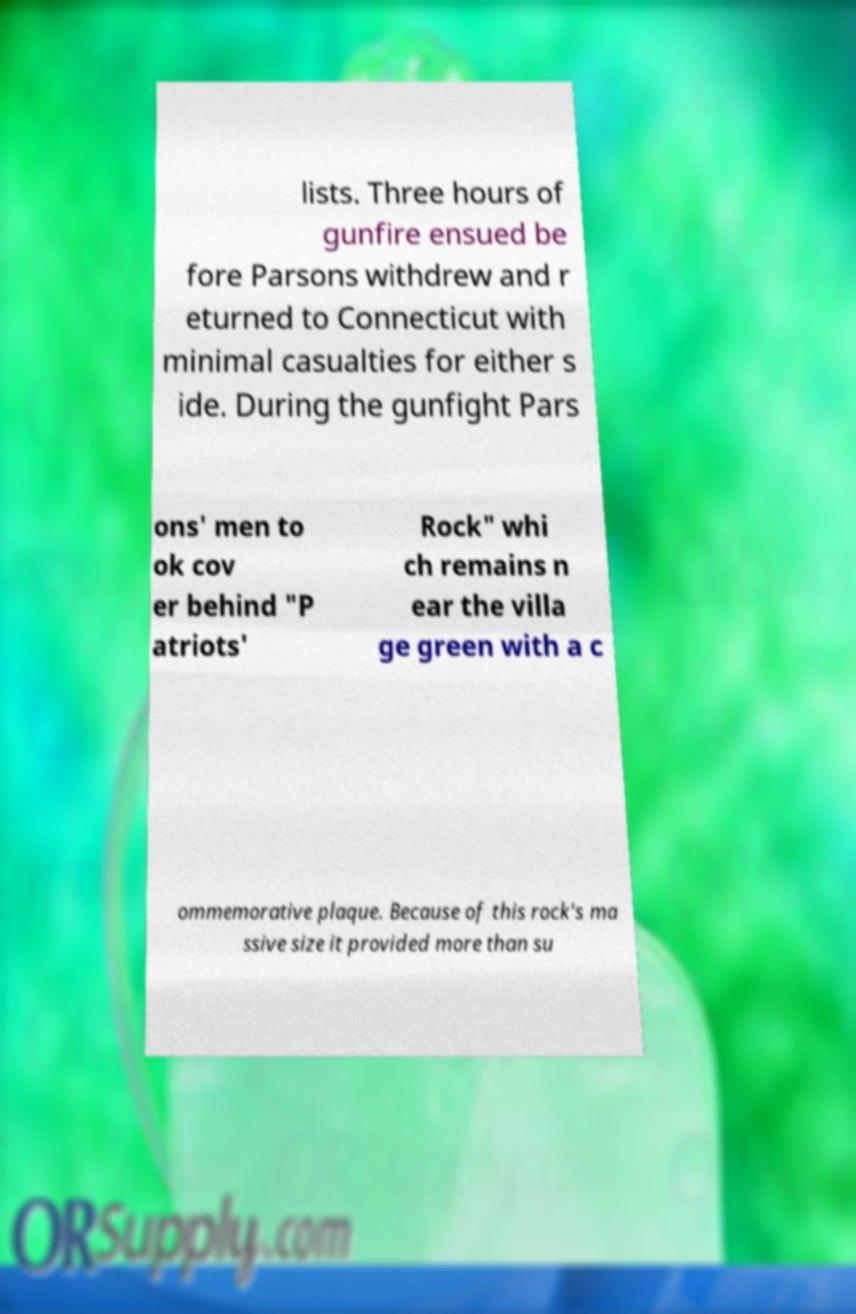Can you accurately transcribe the text from the provided image for me? lists. Three hours of gunfire ensued be fore Parsons withdrew and r eturned to Connecticut with minimal casualties for either s ide. During the gunfight Pars ons' men to ok cov er behind "P atriots' Rock" whi ch remains n ear the villa ge green with a c ommemorative plaque. Because of this rock's ma ssive size it provided more than su 